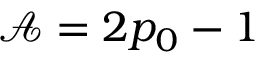Convert formula to latex. <formula><loc_0><loc_0><loc_500><loc_500>\mathcal { A } = 2 p _ { 0 } - 1</formula> 